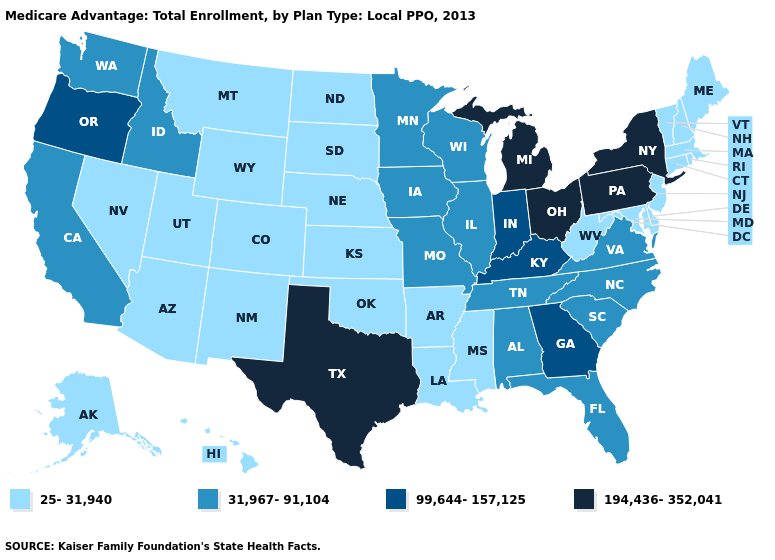Name the states that have a value in the range 31,967-91,104?
Answer briefly. Alabama, California, Florida, Iowa, Idaho, Illinois, Minnesota, Missouri, North Carolina, South Carolina, Tennessee, Virginia, Washington, Wisconsin. Name the states that have a value in the range 31,967-91,104?
Quick response, please. Alabama, California, Florida, Iowa, Idaho, Illinois, Minnesota, Missouri, North Carolina, South Carolina, Tennessee, Virginia, Washington, Wisconsin. What is the value of Minnesota?
Be succinct. 31,967-91,104. Among the states that border Massachusetts , which have the highest value?
Answer briefly. New York. Does Massachusetts have the same value as Idaho?
Concise answer only. No. Among the states that border Virginia , which have the highest value?
Give a very brief answer. Kentucky. Which states have the lowest value in the USA?
Concise answer only. Alaska, Arkansas, Arizona, Colorado, Connecticut, Delaware, Hawaii, Kansas, Louisiana, Massachusetts, Maryland, Maine, Mississippi, Montana, North Dakota, Nebraska, New Hampshire, New Jersey, New Mexico, Nevada, Oklahoma, Rhode Island, South Dakota, Utah, Vermont, West Virginia, Wyoming. Name the states that have a value in the range 194,436-352,041?
Keep it brief. Michigan, New York, Ohio, Pennsylvania, Texas. Is the legend a continuous bar?
Answer briefly. No. Does Pennsylvania have the lowest value in the Northeast?
Quick response, please. No. What is the lowest value in the USA?
Concise answer only. 25-31,940. What is the highest value in the USA?
Answer briefly. 194,436-352,041. What is the value of New York?
Short answer required. 194,436-352,041. Is the legend a continuous bar?
Give a very brief answer. No. 